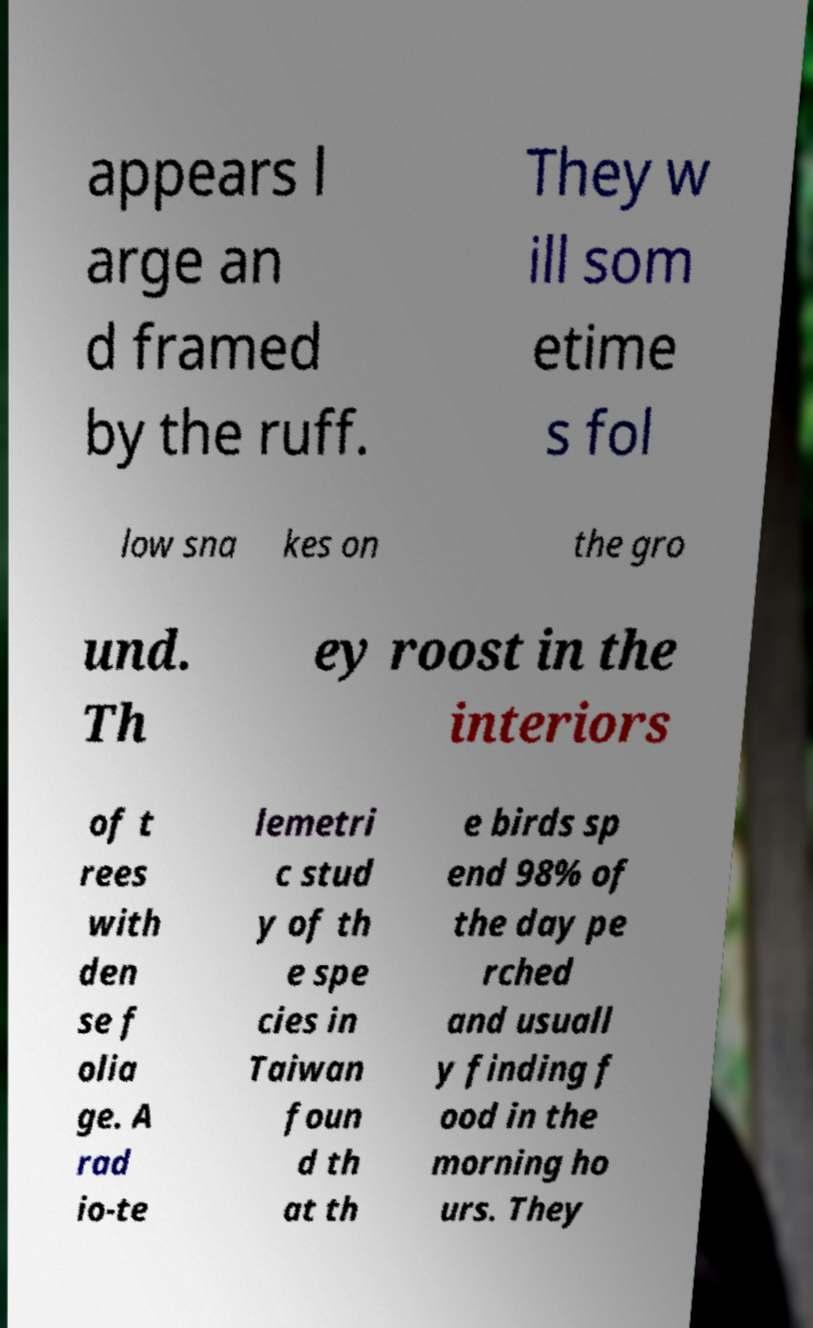Can you read and provide the text displayed in the image?This photo seems to have some interesting text. Can you extract and type it out for me? appears l arge an d framed by the ruff. They w ill som etime s fol low sna kes on the gro und. Th ey roost in the interiors of t rees with den se f olia ge. A rad io-te lemetri c stud y of th e spe cies in Taiwan foun d th at th e birds sp end 98% of the day pe rched and usuall y finding f ood in the morning ho urs. They 